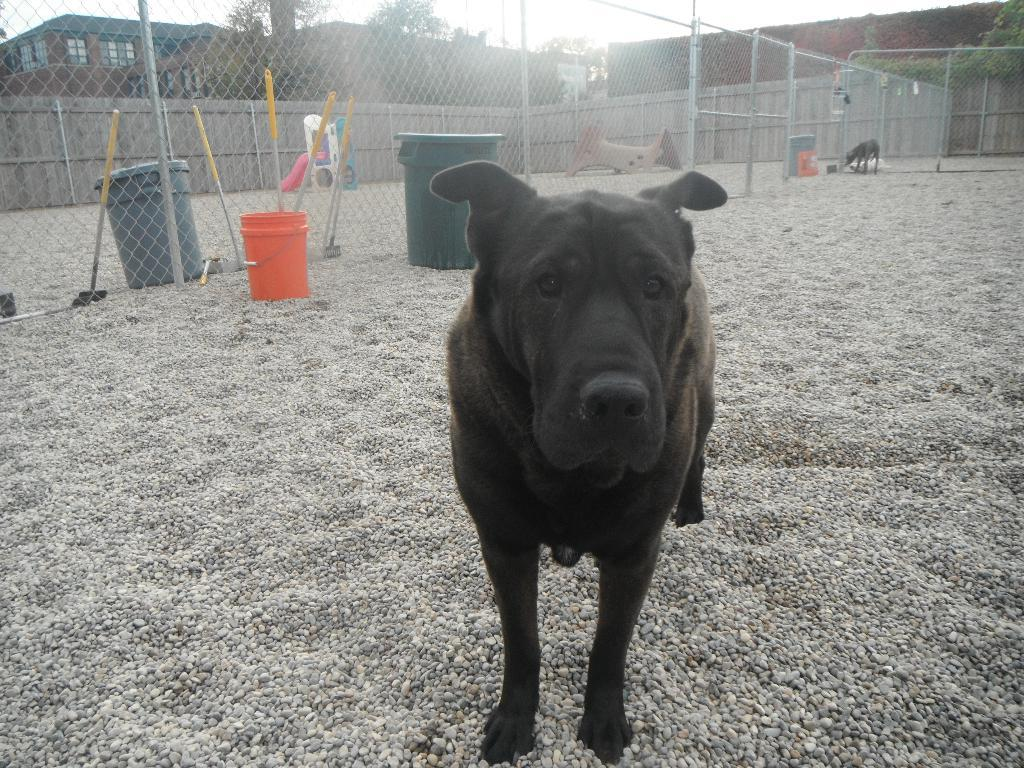What type of animal can be seen in the image? There is a dog in the image. Can you describe the color of the dog? The dog is black in color. What type of terrain is visible in the image? There is sand in the image. What object can be used for storage or transportation? There is a container in the image. What structure is present to separate or enclose an area? There is a fence in the image. What type of vegetation is present in the image? There is a plant in the image. What type of man-made structure is visible in the image? There is a building in the image. What feature allows light to enter the building? There are windows on the building. What part of the natural environment is visible in the image? The sky is visible in the image. What other type of animal can be seen in the image? There is another animal in the image. Can you see a plane flying in the sky in the image? There is no plane visible in the sky in the image. Is there a stream of water flowing through the sand in the image? There is no stream of water visible in the image. Can you see a person interacting with the dog in the image? There is no person visible in the image. 